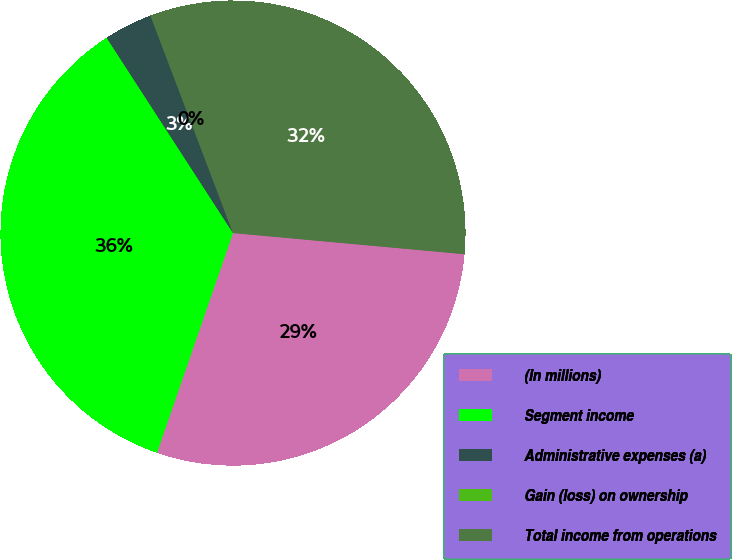Convert chart. <chart><loc_0><loc_0><loc_500><loc_500><pie_chart><fcel>(In millions)<fcel>Segment income<fcel>Administrative expenses (a)<fcel>Gain (loss) on ownership<fcel>Total income from operations<nl><fcel>28.85%<fcel>35.56%<fcel>3.37%<fcel>0.01%<fcel>32.21%<nl></chart> 